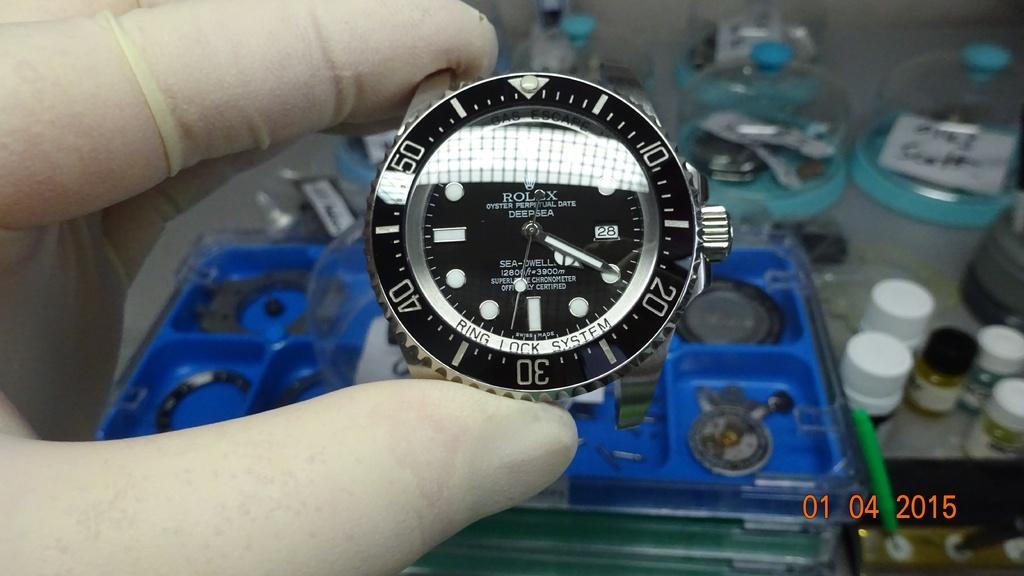<image>
Relay a brief, clear account of the picture shown. A ring lock system rolex watch face from 1/4/15. 